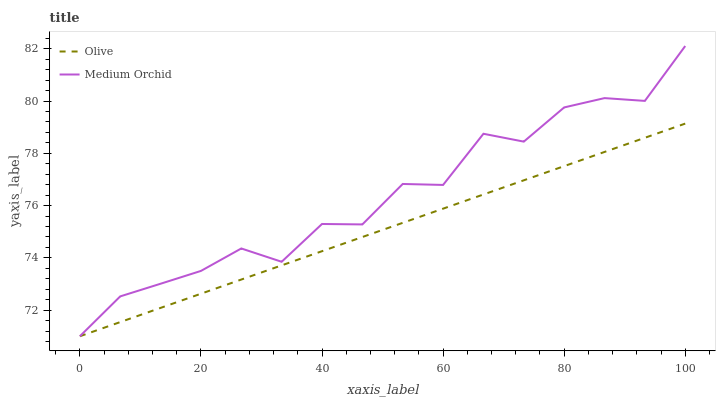Does Olive have the minimum area under the curve?
Answer yes or no. Yes. Does Medium Orchid have the maximum area under the curve?
Answer yes or no. Yes. Does Medium Orchid have the minimum area under the curve?
Answer yes or no. No. Is Olive the smoothest?
Answer yes or no. Yes. Is Medium Orchid the roughest?
Answer yes or no. Yes. Is Medium Orchid the smoothest?
Answer yes or no. No. Does Olive have the lowest value?
Answer yes or no. Yes. Does Medium Orchid have the highest value?
Answer yes or no. Yes. Does Medium Orchid intersect Olive?
Answer yes or no. Yes. Is Medium Orchid less than Olive?
Answer yes or no. No. Is Medium Orchid greater than Olive?
Answer yes or no. No. 